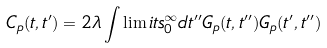<formula> <loc_0><loc_0><loc_500><loc_500>C _ { p } ( t , t ^ { \prime } ) = 2 \lambda \int \lim i t s _ { 0 } ^ { \infty } d t ^ { \prime \prime } G _ { p } ( t , t ^ { \prime \prime } ) G _ { p } ( t ^ { \prime } , t ^ { \prime \prime } )</formula> 